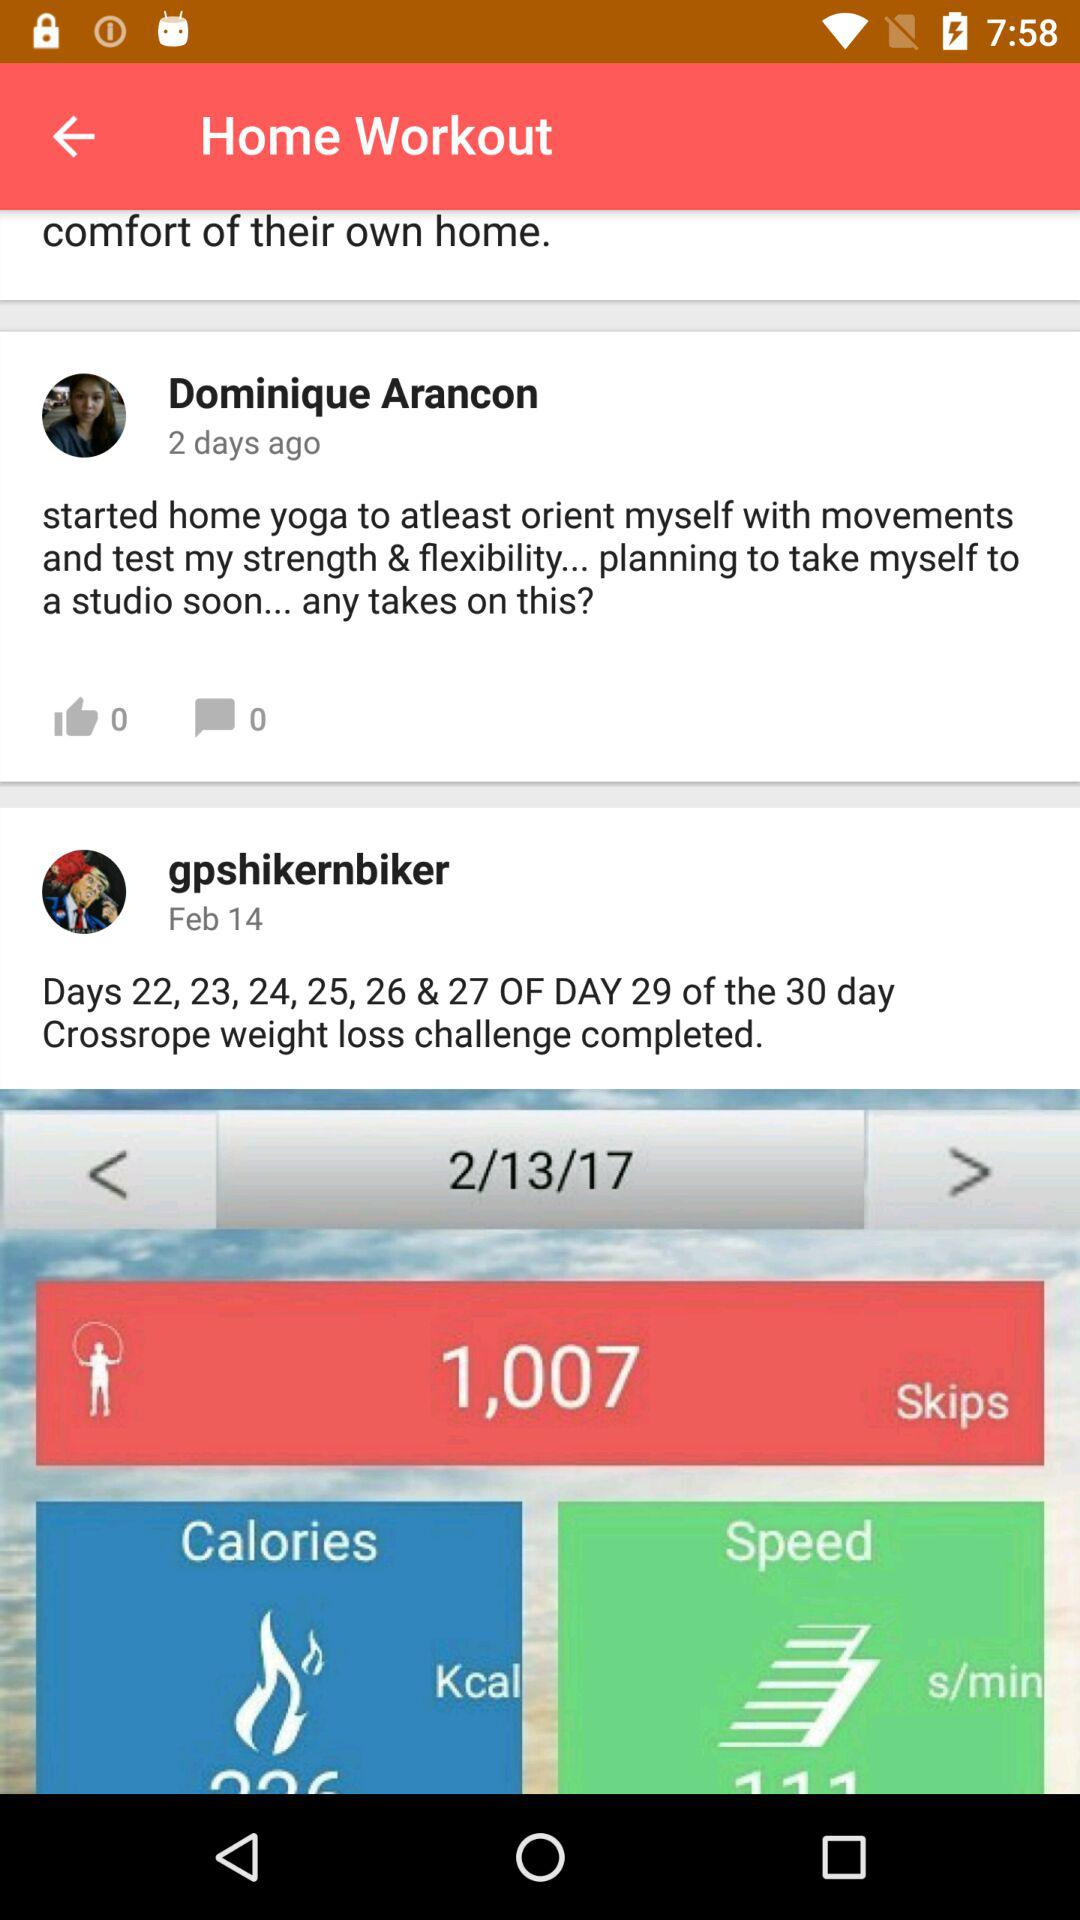When was the post by Dominique Arancon posted? The post by Dominique Arancon was posted 2 days ago. 